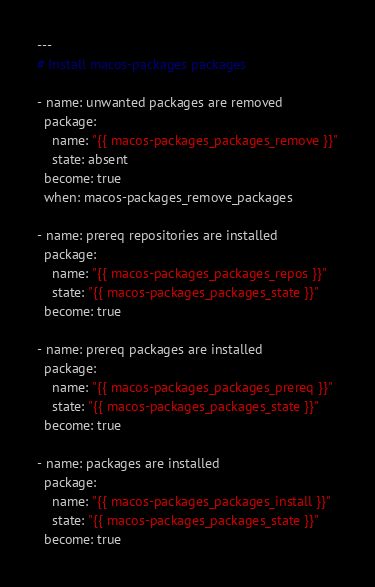Convert code to text. <code><loc_0><loc_0><loc_500><loc_500><_YAML_>---
# Install macos-packages packages

- name: unwanted packages are removed
  package:
    name: "{{ macos-packages_packages_remove }}"
    state: absent
  become: true
  when: macos-packages_remove_packages

- name: prereq repositories are installed
  package:
    name: "{{ macos-packages_packages_repos }}"
    state: "{{ macos-packages_packages_state }}"
  become: true

- name: prereq packages are installed
  package:
    name: "{{ macos-packages_packages_prereq }}"
    state: "{{ macos-packages_packages_state }}"
  become: true

- name: packages are installed
  package:
    name: "{{ macos-packages_packages_install }}"
    state: "{{ macos-packages_packages_state }}"
  become: true
</code> 